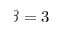<formula> <loc_0><loc_0><loc_500><loc_500>\beta = 3</formula> 